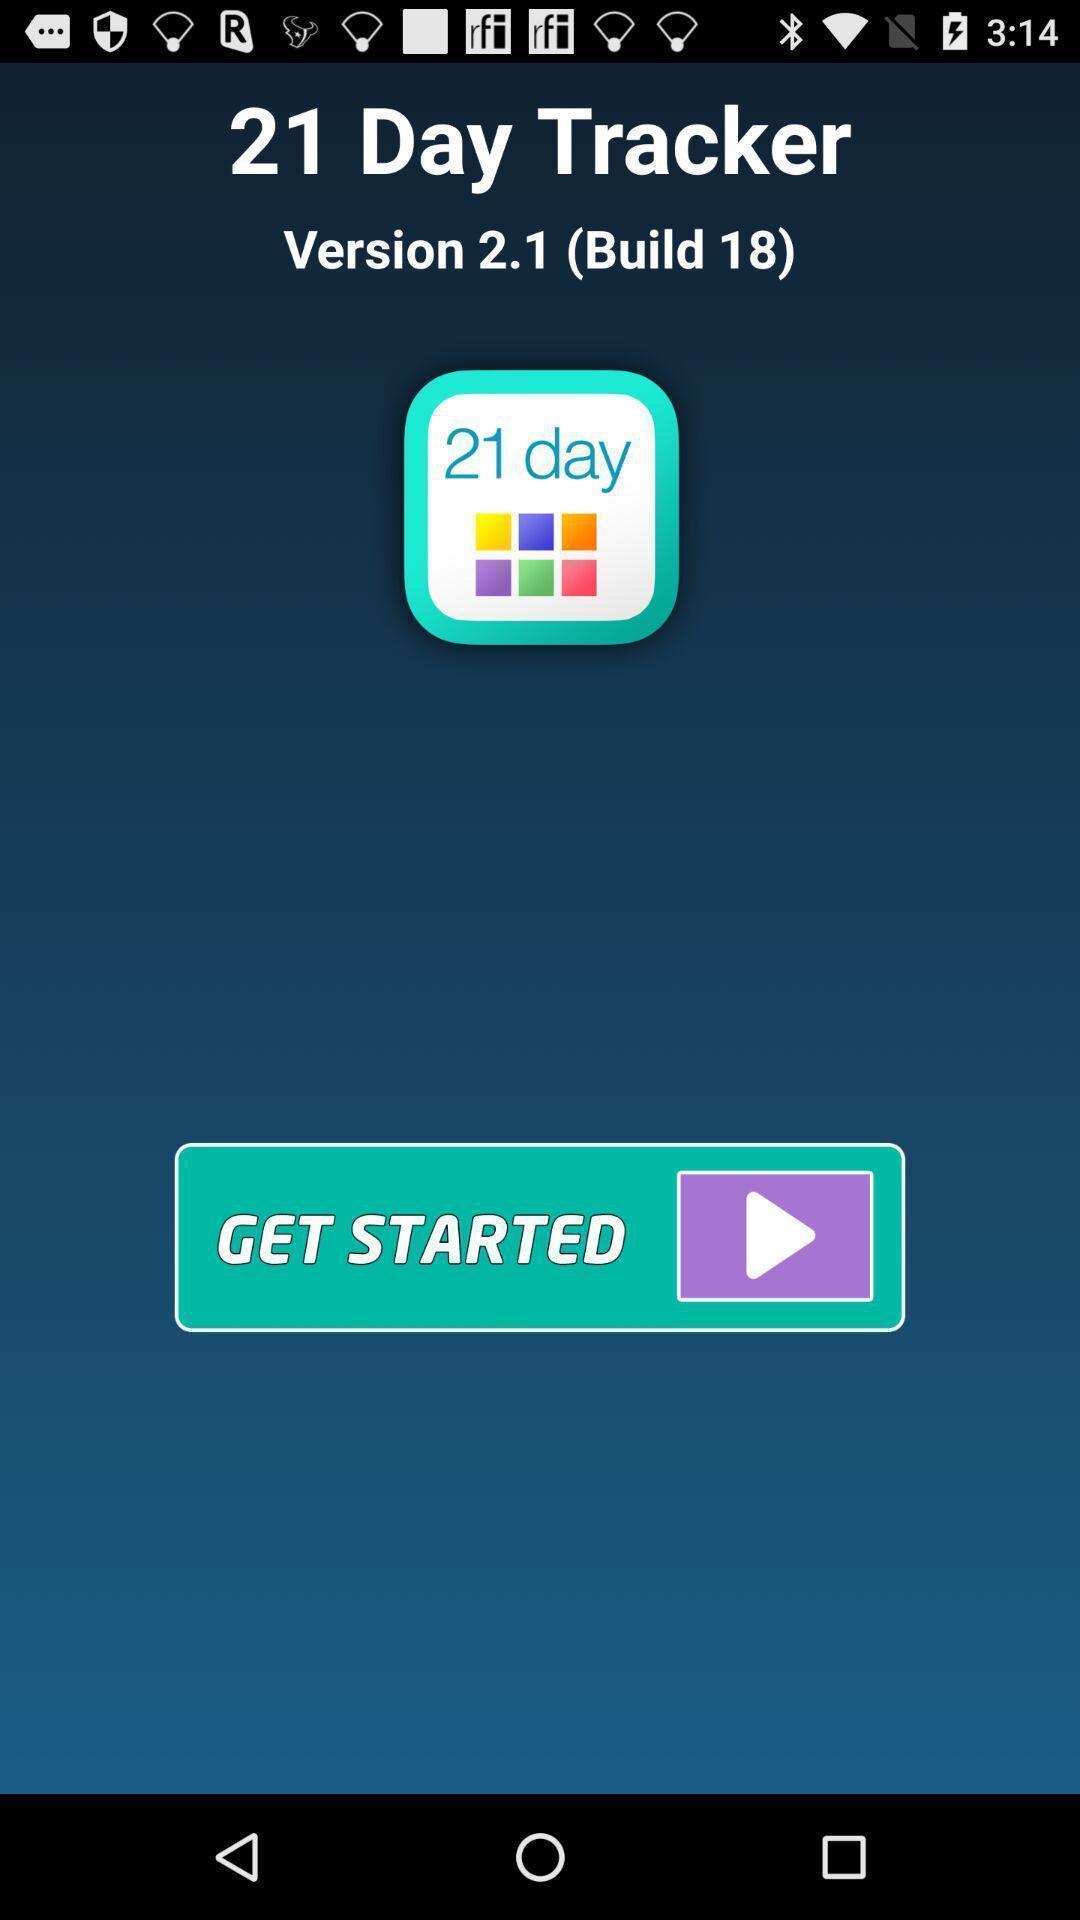Give me a summary of this screen capture. Welcome page. 